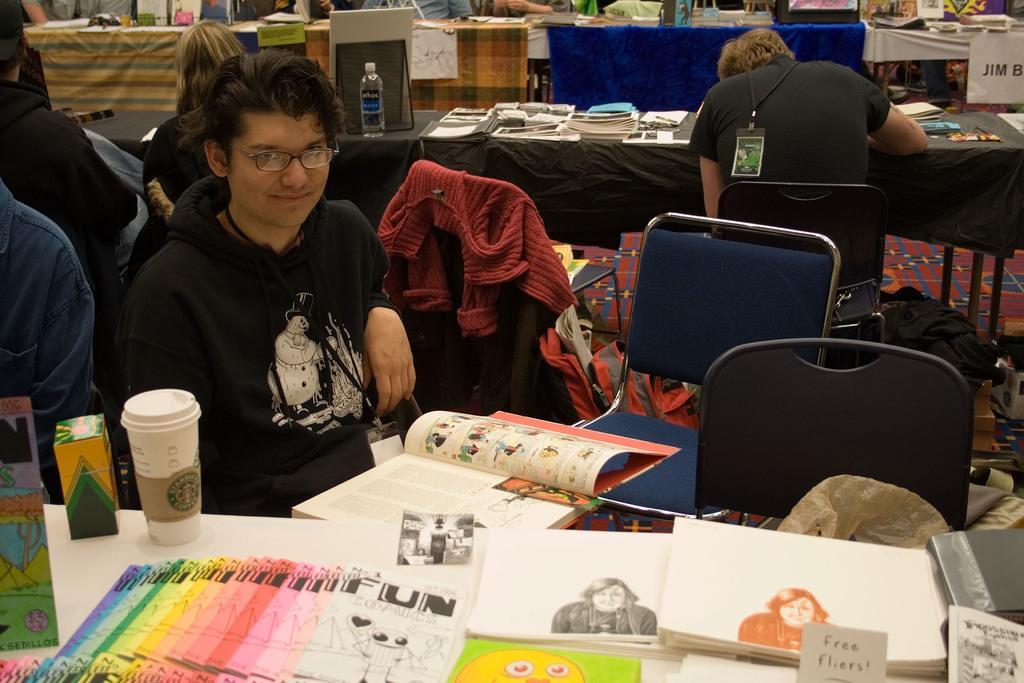How would you summarize this image in a sentence or two? In this image we can see people sitting. There are tables and we can see books, bottle, papers, glass, carton, boards and some objects placed on the tables. There are clothes and we can see chairs. 